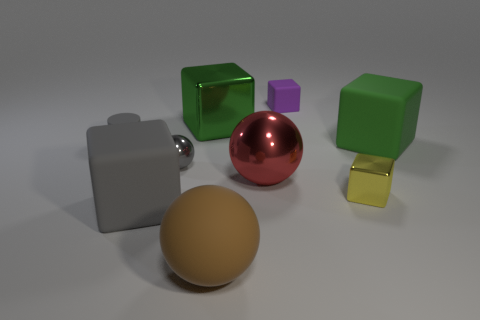Subtract all tiny blocks. How many blocks are left? 3 Subtract all yellow blocks. How many blocks are left? 4 Subtract 2 spheres. How many spheres are left? 1 Subtract all green balls. How many green cubes are left? 2 Subtract all cylinders. How many objects are left? 8 Add 5 gray matte blocks. How many gray matte blocks are left? 6 Add 8 big brown rubber objects. How many big brown rubber objects exist? 9 Subtract 0 blue balls. How many objects are left? 9 Subtract all yellow cylinders. Subtract all brown blocks. How many cylinders are left? 1 Subtract all rubber blocks. Subtract all tiny metallic things. How many objects are left? 4 